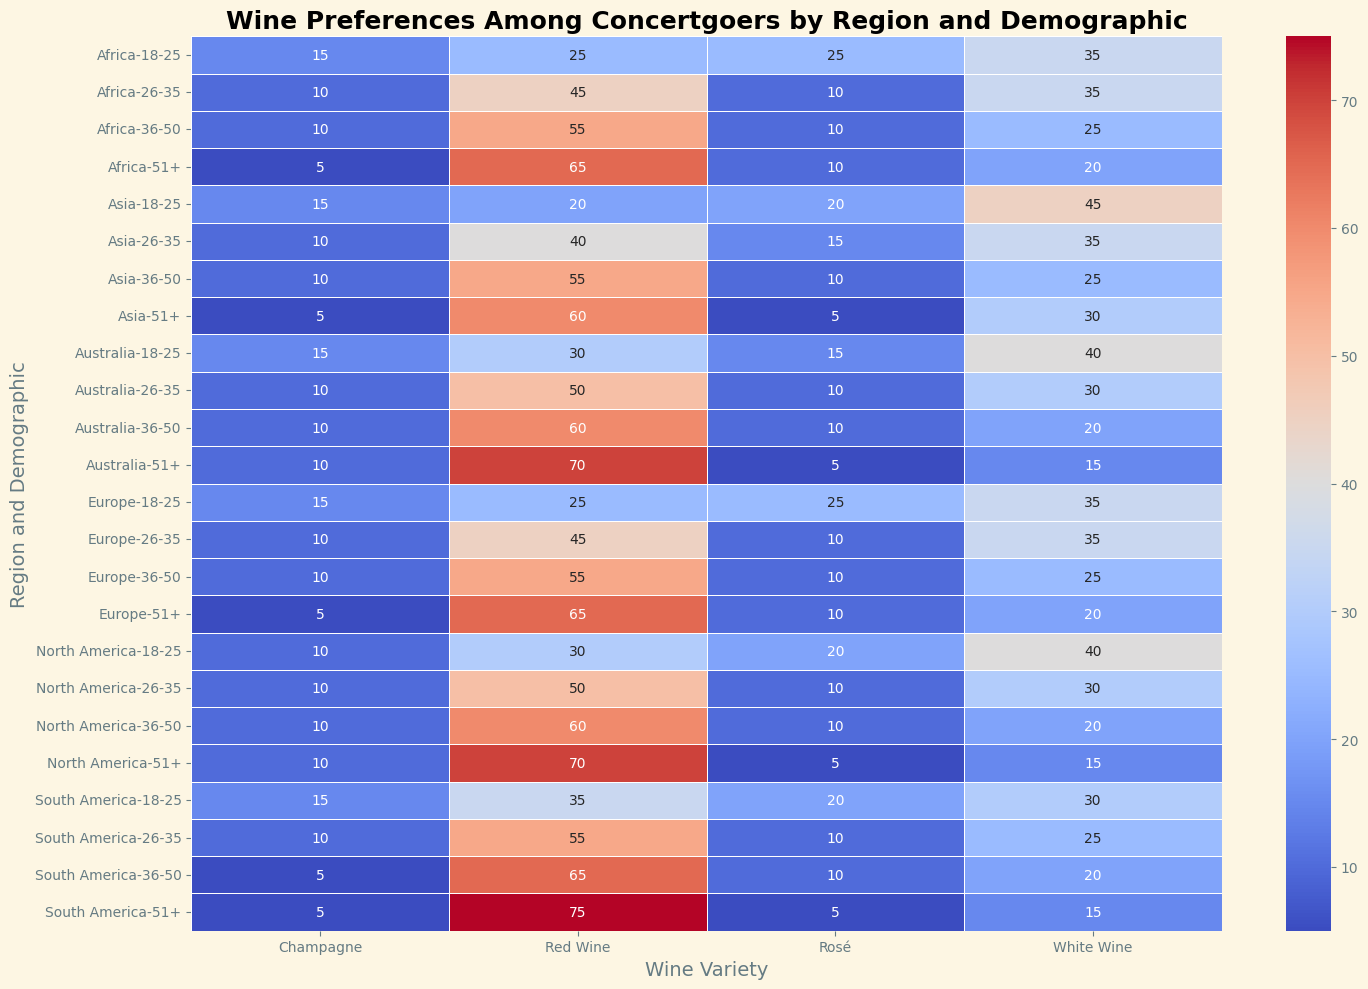Which region and demographic has the highest preference for Red Wine? In the heatmap, identify the darkest red cell corresponding to Red Wine preferences. The darkest red cell appears under South America, 51+ demographic.
Answer: South America, 51+ Which regions have higher Champagne preference among 18-25 demographics compared to 51+ demographics? Check the heatmap for Champagne preferences. Compare 18-25 and 51+ demographics across all regions. North America, Europe, Asia, South America, and Africa show higher Champagne preference in 18-25 demographic compared to their 51+ counterparts.
Answer: North America, Europe, Asia, South America, Africa How much more do North America concertgoers aged 51+ prefer Red Wine compared to those aged 18-25? Find the Red Wine values for North America, 51+ and 18-25 demographics. Red Wine preference for 51+ is 70, and for 18-25 it is 30. The difference is 70 - 30.
Answer: 40 What is the average preference for White Wine among concertgoers aged 26-35 in Europe and Asia? Sum the White Wine values for Europe and Asia in the 26-35 demographic, then divide by 2. Europe has 35 and Asia has 35, so (35 + 35) / 2 = 35.
Answer: 35 Is Rosé more popular in the 18-25 age group or the 26-35 age group across all regions? Compare the heatmap values for Rosé in both age groups across regions and sum them. The sum for 18-25 is 95, and the sum for 26-35 is 55. Thus, Rosé is more popular in the 18-25 age group.
Answer: 18-25 age group Which region and demographic has the least preference for Champagne? Identify the lightest-colored cell under the Champagne column in the heatmap. This appears under Asia, 51+ demographic and South America, 51+ demographic both with a preference of 5.
Answer: Asia, 51+ and South America, 51+ Which two regions have identical preferences for Red Wine in the 26-35 demographic? Look at the heatmap for the Red Wine preferences under the 26-35 demographic. North America and Australia both show a preference of 50 for Red Wine.
Answer: North America and Australia In which demographic does Red Wine preference in Africa drop compared to Europe? Compare the Red Wine preferences between Africa and Europe across demographics. Preferences drop in 18-25, 26-35, and 36-50 demographics.
Answer: 18-25, 26-35, 36-50 